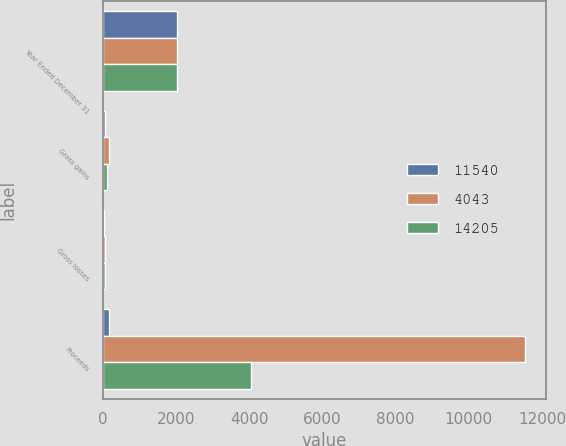<chart> <loc_0><loc_0><loc_500><loc_500><stacked_bar_chart><ecel><fcel>Year Ended December 31<fcel>Gross gains<fcel>Gross losses<fcel>Proceeds<nl><fcel>11540<fcel>2017<fcel>68<fcel>32<fcel>152<nl><fcel>4043<fcel>2016<fcel>152<fcel>51<fcel>11540<nl><fcel>14205<fcel>2015<fcel>103<fcel>42<fcel>4043<nl></chart> 